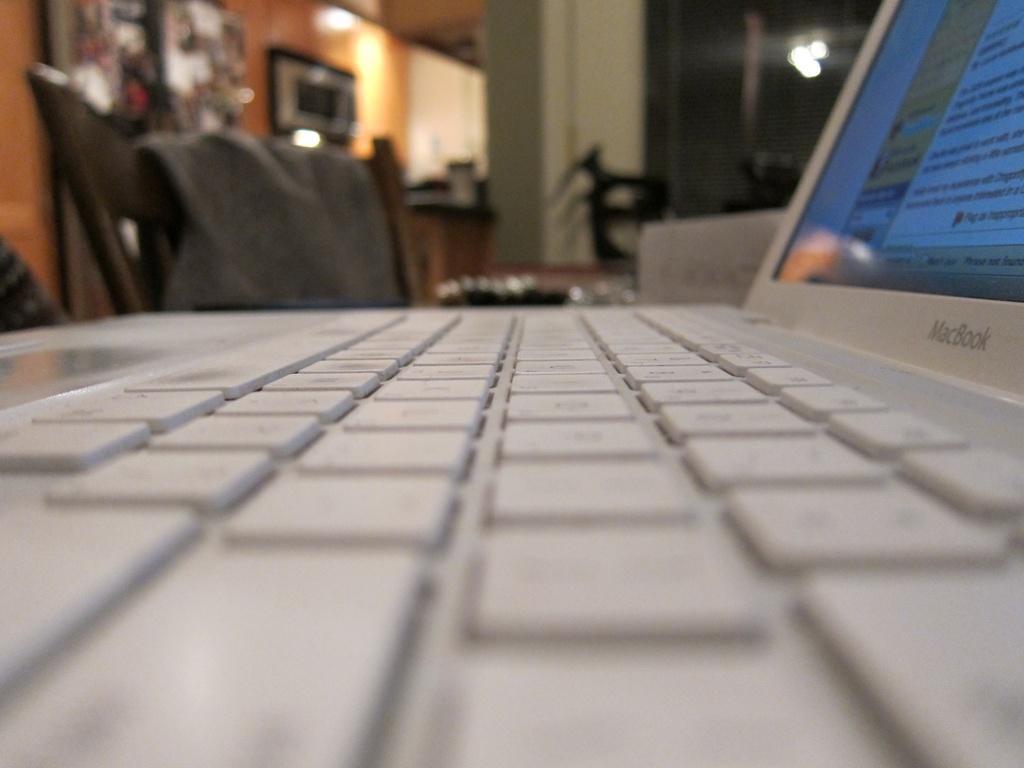Could you give a brief overview of what you see in this image? In this image, we can see a laptop and a chair, we can see the wall. We can see a window. 